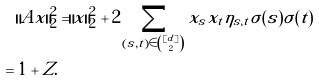<formula> <loc_0><loc_0><loc_500><loc_500>\| A x \| _ { 2 } ^ { 2 } & = \| x \| _ { 2 } ^ { 2 } + 2 \sum _ { ( s , t ) \in \binom { [ d ] } { 2 } } x _ { s } x _ { t } \eta _ { s , t } \sigma ( s ) \sigma ( t ) \\ = 1 + Z .</formula> 